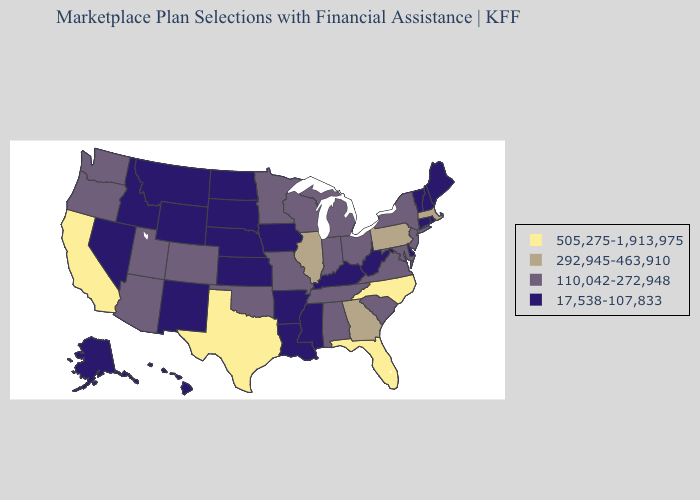Name the states that have a value in the range 505,275-1,913,975?
Be succinct. California, Florida, North Carolina, Texas. Does Wyoming have the lowest value in the USA?
Give a very brief answer. Yes. Among the states that border Kansas , does Missouri have the lowest value?
Quick response, please. No. What is the lowest value in the USA?
Write a very short answer. 17,538-107,833. Among the states that border Massachusetts , which have the lowest value?
Keep it brief. Connecticut, New Hampshire, Rhode Island, Vermont. What is the lowest value in the USA?
Write a very short answer. 17,538-107,833. Does Alaska have the same value as Rhode Island?
Give a very brief answer. Yes. Does Arkansas have the lowest value in the USA?
Answer briefly. Yes. What is the value of Wisconsin?
Give a very brief answer. 110,042-272,948. Does the map have missing data?
Keep it brief. No. What is the value of Arizona?
Answer briefly. 110,042-272,948. Does Utah have the lowest value in the USA?
Write a very short answer. No. What is the lowest value in the USA?
Concise answer only. 17,538-107,833. What is the highest value in the USA?
Short answer required. 505,275-1,913,975. Name the states that have a value in the range 292,945-463,910?
Write a very short answer. Georgia, Illinois, Massachusetts, Pennsylvania. 